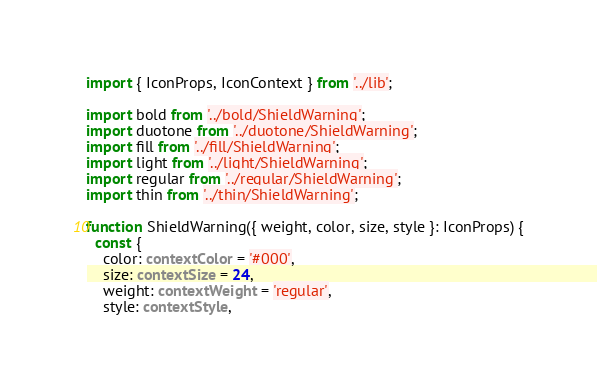<code> <loc_0><loc_0><loc_500><loc_500><_TypeScript_>import { IconProps, IconContext } from '../lib';

import bold from '../bold/ShieldWarning';
import duotone from '../duotone/ShieldWarning';
import fill from '../fill/ShieldWarning';
import light from '../light/ShieldWarning';
import regular from '../regular/ShieldWarning';
import thin from '../thin/ShieldWarning';

function ShieldWarning({ weight, color, size, style }: IconProps) {
  const {
    color: contextColor = '#000',
    size: contextSize = 24,
    weight: contextWeight = 'regular',
    style: contextStyle,</code> 